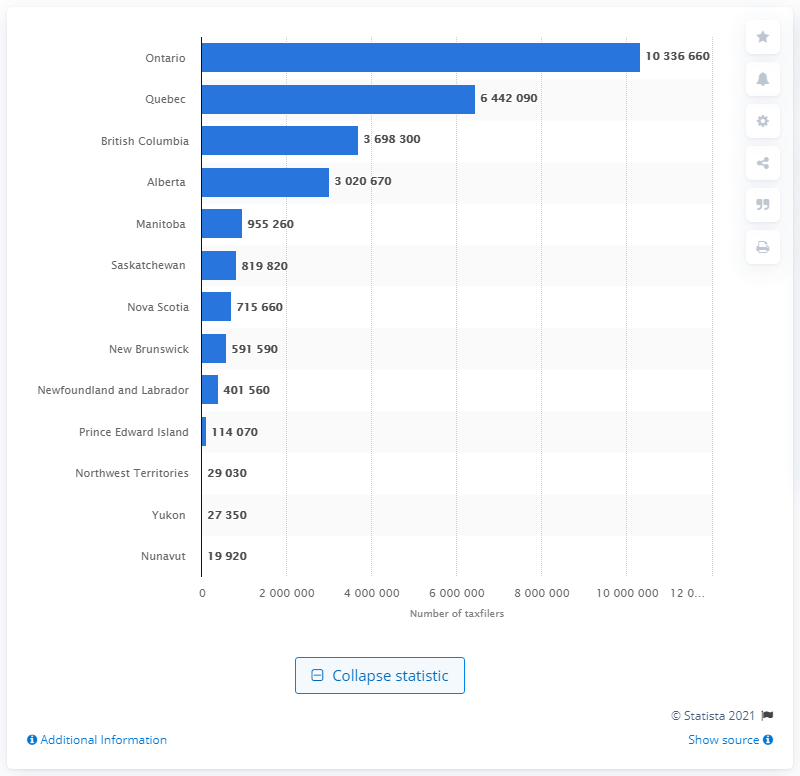Point out several critical features in this image. In 2019, a total of 10,336,660 Ontarians filed an income tax return. 